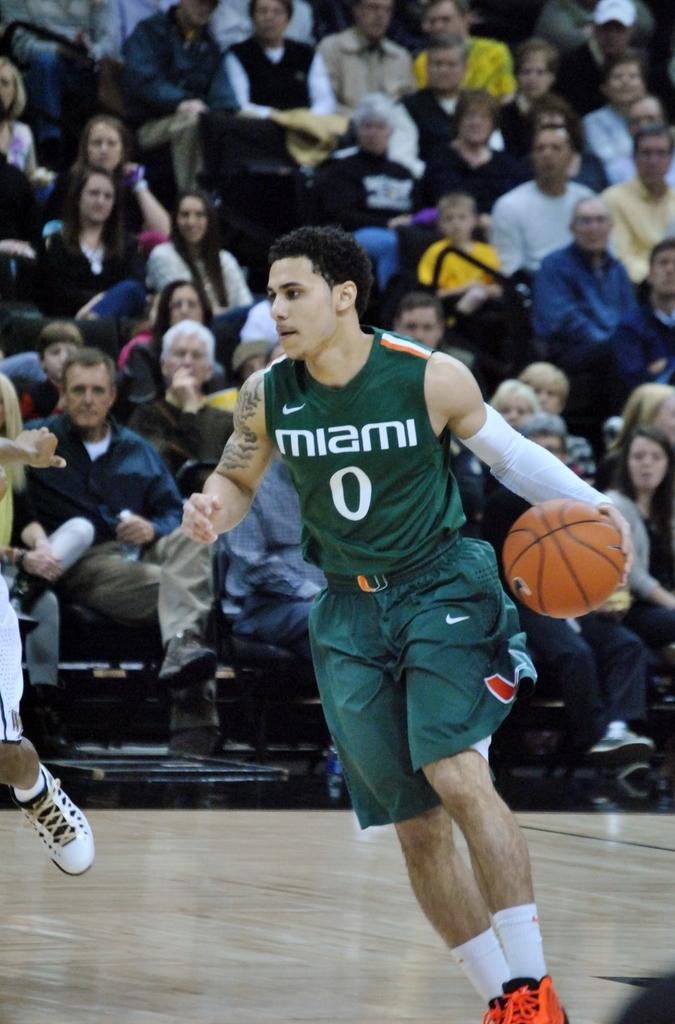What is the person in the image doing? The person in the image is running. What is the person holding while running? The person is holding a basketball. What are the people in the background doing? The people in the background are sitting and watching. What type of farm animals can be seen in the image? There are no farm animals present in the image; it features a person running with a basketball and people sitting and watching. 